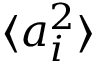Convert formula to latex. <formula><loc_0><loc_0><loc_500><loc_500>\langle a _ { i } ^ { 2 } \rangle</formula> 